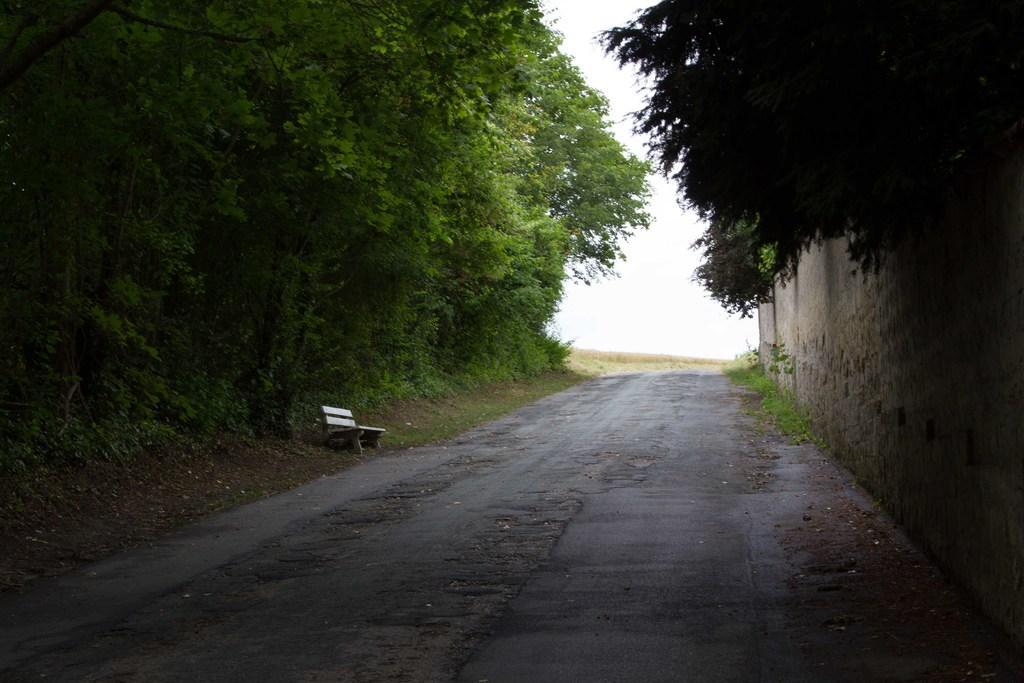Describe this image in one or two sentences. There is a way and a bench in the foreground and there is greenery and sky in the background area. There is a wall on the right side. 